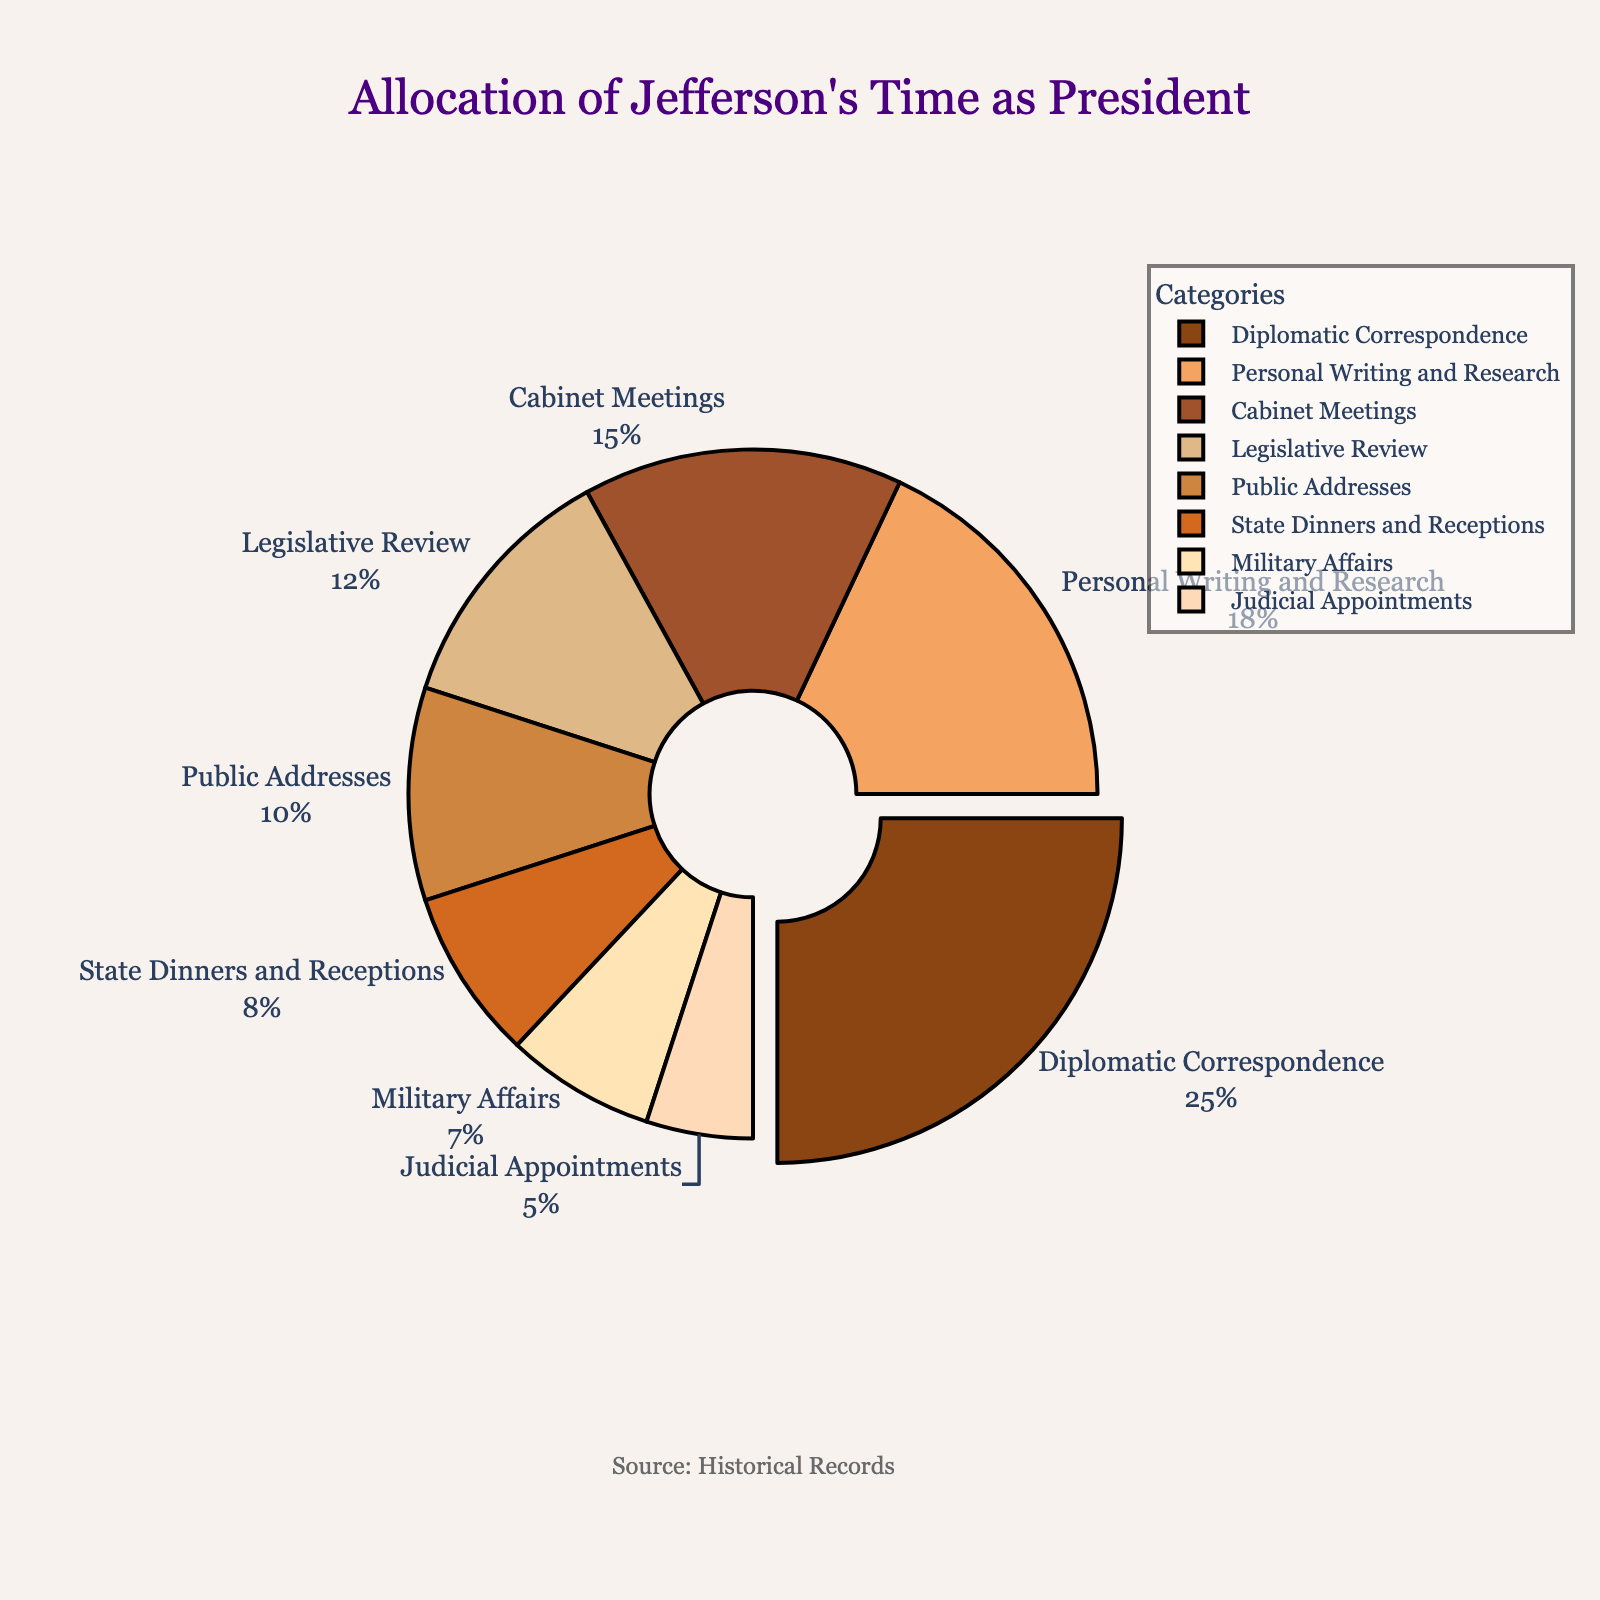Which category occupies the largest portion of Jefferson's time? The largest portion can be seen from the pie chart as the segment that is pulled out from the rest. This segment represents Diplomatic Correspondence.
Answer: Diplomatic Correspondence How much time in total does Jefferson spend on Diplomatic Correspondence and Legislative Review? Add the percentages of the two categories: Diplomatic Correspondence (25%) and Legislative Review (12%). So, 25 + 12 = 37%
Answer: 37% How much more time does Jefferson spend on Public Addresses compared to Judicial Appointments? Subtract the percentage of time spent on Judicial Appointments (5%) from the percentage of time spent on Public Addresses (10%). So, 10 - 5 = 5%
Answer: 5% Which categories together make up more than 50% of Jefferson's time? Sum the percentages of each category until the total exceeds 50%: Diplomatic Correspondence (25%) + Cabinet Meetings (15%) + Personal Writing and Research (18%). Collectively these categories sum to 25 + 15 + 18 = 58%.
Answer: Diplomatic Correspondence, Cabinet Meetings, Personal Writing and Research What is the combined percentage of time spent on State Dinners and Receptions, and Military Affairs? Add the percentages of the two categories: State Dinners and Receptions (8%) and Military Affairs (7%). So, 8 + 7 = 15%.
Answer: 15% Which two categories have the closest time allocations? Compare the percentages of each category to find the smallest difference. The smallest difference is between Legislative Review (12%) and Personal Writing and Research (18%), which is a difference of 6%.
Answer: Legislative Review and Personal Writing and Research What fraction of Jefferson's time is occupied by non-political activities, namely, State Dinners and Receptions, and Personal Writing and Research? Add the percentages of the two categories: State Dinners and Receptions (8%) and Personal Writing and Research (18%). So, 8 + 18 = 26%
Answer: 26% If an analyst mistakenly categorized "State Dinners and Receptions" as "Public Addresses", what would be the new percentage for the combined category? Add the two percentages wrongly grouped: State Dinners and Receptions (8%) + Public Addresses (10%). So, 8 + 10 = 18%
Answer: 18% How does the allocation of time for Diplomatic Correspondence compare to the combined allocation for Military Affairs and Judicial Appointments? Compare 25% (Diplomatic Correspondence) to the sum of Military Affairs (7%) and Judicial Appointments (5%): 7 + 5 = 12%. Thus, 25% is greater than 12%.
Answer: Diplomatic Correspondence > Military Affairs and Judicial Appointments 